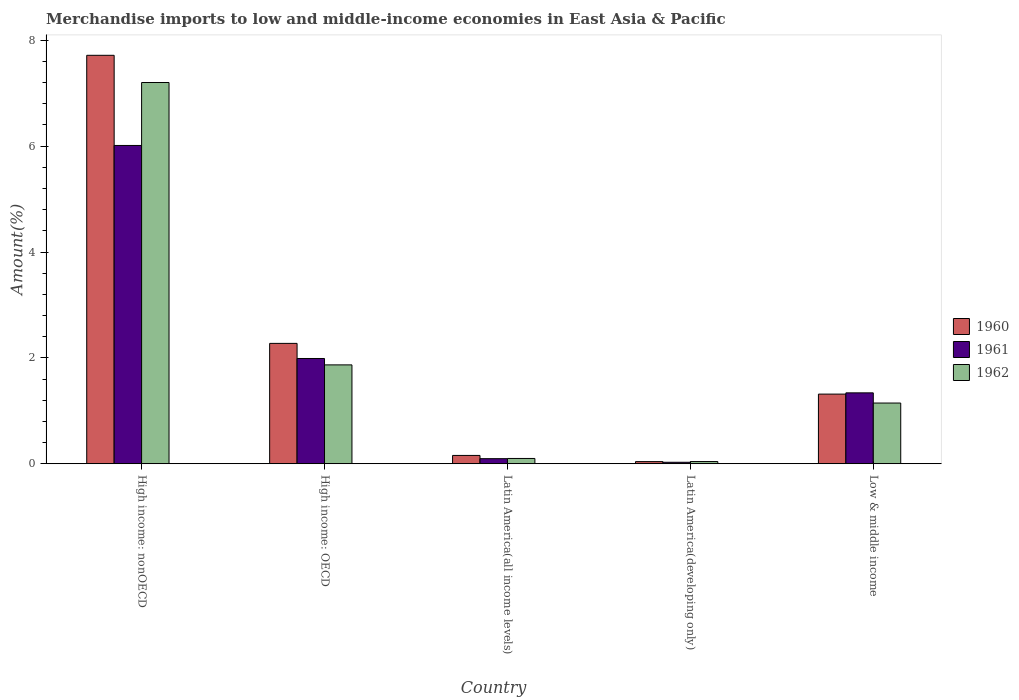How many different coloured bars are there?
Offer a terse response. 3. Are the number of bars per tick equal to the number of legend labels?
Provide a short and direct response. Yes. Are the number of bars on each tick of the X-axis equal?
Your answer should be very brief. Yes. In how many cases, is the number of bars for a given country not equal to the number of legend labels?
Give a very brief answer. 0. What is the percentage of amount earned from merchandise imports in 1962 in Latin America(all income levels)?
Provide a succinct answer. 0.1. Across all countries, what is the maximum percentage of amount earned from merchandise imports in 1961?
Ensure brevity in your answer.  6.01. Across all countries, what is the minimum percentage of amount earned from merchandise imports in 1961?
Your answer should be compact. 0.03. In which country was the percentage of amount earned from merchandise imports in 1961 maximum?
Give a very brief answer. High income: nonOECD. In which country was the percentage of amount earned from merchandise imports in 1960 minimum?
Offer a terse response. Latin America(developing only). What is the total percentage of amount earned from merchandise imports in 1961 in the graph?
Your answer should be compact. 9.46. What is the difference between the percentage of amount earned from merchandise imports in 1962 in Latin America(all income levels) and that in Low & middle income?
Make the answer very short. -1.05. What is the difference between the percentage of amount earned from merchandise imports in 1962 in Latin America(all income levels) and the percentage of amount earned from merchandise imports in 1960 in High income: OECD?
Your answer should be compact. -2.17. What is the average percentage of amount earned from merchandise imports in 1960 per country?
Provide a short and direct response. 2.3. What is the difference between the percentage of amount earned from merchandise imports of/in 1961 and percentage of amount earned from merchandise imports of/in 1962 in Low & middle income?
Provide a short and direct response. 0.19. In how many countries, is the percentage of amount earned from merchandise imports in 1961 greater than 2.4 %?
Make the answer very short. 1. What is the ratio of the percentage of amount earned from merchandise imports in 1961 in Latin America(all income levels) to that in Low & middle income?
Your response must be concise. 0.07. Is the difference between the percentage of amount earned from merchandise imports in 1961 in High income: OECD and Low & middle income greater than the difference between the percentage of amount earned from merchandise imports in 1962 in High income: OECD and Low & middle income?
Make the answer very short. No. What is the difference between the highest and the second highest percentage of amount earned from merchandise imports in 1962?
Offer a terse response. 0.72. What is the difference between the highest and the lowest percentage of amount earned from merchandise imports in 1961?
Your response must be concise. 5.99. Is the sum of the percentage of amount earned from merchandise imports in 1960 in High income: OECD and Latin America(all income levels) greater than the maximum percentage of amount earned from merchandise imports in 1962 across all countries?
Give a very brief answer. No. What does the 2nd bar from the left in High income: nonOECD represents?
Your answer should be compact. 1961. Is it the case that in every country, the sum of the percentage of amount earned from merchandise imports in 1962 and percentage of amount earned from merchandise imports in 1960 is greater than the percentage of amount earned from merchandise imports in 1961?
Ensure brevity in your answer.  Yes. Are all the bars in the graph horizontal?
Offer a very short reply. No. Are the values on the major ticks of Y-axis written in scientific E-notation?
Offer a terse response. No. Does the graph contain any zero values?
Give a very brief answer. No. What is the title of the graph?
Keep it short and to the point. Merchandise imports to low and middle-income economies in East Asia & Pacific. Does "1972" appear as one of the legend labels in the graph?
Provide a succinct answer. No. What is the label or title of the Y-axis?
Provide a short and direct response. Amount(%). What is the Amount(%) of 1960 in High income: nonOECD?
Offer a terse response. 7.72. What is the Amount(%) of 1961 in High income: nonOECD?
Provide a succinct answer. 6.01. What is the Amount(%) in 1962 in High income: nonOECD?
Keep it short and to the point. 7.2. What is the Amount(%) of 1960 in High income: OECD?
Offer a very short reply. 2.27. What is the Amount(%) of 1961 in High income: OECD?
Your answer should be very brief. 1.99. What is the Amount(%) of 1962 in High income: OECD?
Make the answer very short. 1.87. What is the Amount(%) of 1960 in Latin America(all income levels)?
Provide a succinct answer. 0.16. What is the Amount(%) of 1961 in Latin America(all income levels)?
Provide a short and direct response. 0.1. What is the Amount(%) of 1962 in Latin America(all income levels)?
Give a very brief answer. 0.1. What is the Amount(%) in 1960 in Latin America(developing only)?
Offer a very short reply. 0.04. What is the Amount(%) in 1961 in Latin America(developing only)?
Give a very brief answer. 0.03. What is the Amount(%) of 1962 in Latin America(developing only)?
Ensure brevity in your answer.  0.04. What is the Amount(%) of 1960 in Low & middle income?
Give a very brief answer. 1.32. What is the Amount(%) in 1961 in Low & middle income?
Your response must be concise. 1.34. What is the Amount(%) of 1962 in Low & middle income?
Your answer should be very brief. 1.15. Across all countries, what is the maximum Amount(%) in 1960?
Ensure brevity in your answer.  7.72. Across all countries, what is the maximum Amount(%) in 1961?
Keep it short and to the point. 6.01. Across all countries, what is the maximum Amount(%) of 1962?
Give a very brief answer. 7.2. Across all countries, what is the minimum Amount(%) in 1960?
Make the answer very short. 0.04. Across all countries, what is the minimum Amount(%) in 1961?
Ensure brevity in your answer.  0.03. Across all countries, what is the minimum Amount(%) in 1962?
Ensure brevity in your answer.  0.04. What is the total Amount(%) of 1960 in the graph?
Offer a very short reply. 11.5. What is the total Amount(%) of 1961 in the graph?
Offer a terse response. 9.46. What is the total Amount(%) in 1962 in the graph?
Your answer should be compact. 10.36. What is the difference between the Amount(%) of 1960 in High income: nonOECD and that in High income: OECD?
Your response must be concise. 5.44. What is the difference between the Amount(%) of 1961 in High income: nonOECD and that in High income: OECD?
Give a very brief answer. 4.02. What is the difference between the Amount(%) of 1962 in High income: nonOECD and that in High income: OECD?
Offer a terse response. 5.33. What is the difference between the Amount(%) in 1960 in High income: nonOECD and that in Latin America(all income levels)?
Keep it short and to the point. 7.56. What is the difference between the Amount(%) of 1961 in High income: nonOECD and that in Latin America(all income levels)?
Ensure brevity in your answer.  5.92. What is the difference between the Amount(%) of 1962 in High income: nonOECD and that in Latin America(all income levels)?
Offer a terse response. 7.1. What is the difference between the Amount(%) in 1960 in High income: nonOECD and that in Latin America(developing only)?
Make the answer very short. 7.68. What is the difference between the Amount(%) of 1961 in High income: nonOECD and that in Latin America(developing only)?
Keep it short and to the point. 5.99. What is the difference between the Amount(%) in 1962 in High income: nonOECD and that in Latin America(developing only)?
Offer a very short reply. 7.16. What is the difference between the Amount(%) of 1960 in High income: nonOECD and that in Low & middle income?
Make the answer very short. 6.4. What is the difference between the Amount(%) of 1961 in High income: nonOECD and that in Low & middle income?
Offer a terse response. 4.67. What is the difference between the Amount(%) in 1962 in High income: nonOECD and that in Low & middle income?
Offer a very short reply. 6.06. What is the difference between the Amount(%) of 1960 in High income: OECD and that in Latin America(all income levels)?
Make the answer very short. 2.12. What is the difference between the Amount(%) of 1961 in High income: OECD and that in Latin America(all income levels)?
Offer a very short reply. 1.89. What is the difference between the Amount(%) in 1962 in High income: OECD and that in Latin America(all income levels)?
Keep it short and to the point. 1.77. What is the difference between the Amount(%) in 1960 in High income: OECD and that in Latin America(developing only)?
Keep it short and to the point. 2.23. What is the difference between the Amount(%) of 1961 in High income: OECD and that in Latin America(developing only)?
Ensure brevity in your answer.  1.96. What is the difference between the Amount(%) in 1962 in High income: OECD and that in Latin America(developing only)?
Offer a terse response. 1.83. What is the difference between the Amount(%) of 1960 in High income: OECD and that in Low & middle income?
Keep it short and to the point. 0.96. What is the difference between the Amount(%) of 1961 in High income: OECD and that in Low & middle income?
Ensure brevity in your answer.  0.65. What is the difference between the Amount(%) in 1962 in High income: OECD and that in Low & middle income?
Provide a short and direct response. 0.72. What is the difference between the Amount(%) of 1960 in Latin America(all income levels) and that in Latin America(developing only)?
Give a very brief answer. 0.12. What is the difference between the Amount(%) of 1961 in Latin America(all income levels) and that in Latin America(developing only)?
Keep it short and to the point. 0.07. What is the difference between the Amount(%) of 1962 in Latin America(all income levels) and that in Latin America(developing only)?
Give a very brief answer. 0.06. What is the difference between the Amount(%) of 1960 in Latin America(all income levels) and that in Low & middle income?
Make the answer very short. -1.16. What is the difference between the Amount(%) in 1961 in Latin America(all income levels) and that in Low & middle income?
Make the answer very short. -1.24. What is the difference between the Amount(%) of 1962 in Latin America(all income levels) and that in Low & middle income?
Offer a terse response. -1.05. What is the difference between the Amount(%) of 1960 in Latin America(developing only) and that in Low & middle income?
Ensure brevity in your answer.  -1.28. What is the difference between the Amount(%) in 1961 in Latin America(developing only) and that in Low & middle income?
Provide a short and direct response. -1.31. What is the difference between the Amount(%) in 1962 in Latin America(developing only) and that in Low & middle income?
Provide a short and direct response. -1.11. What is the difference between the Amount(%) of 1960 in High income: nonOECD and the Amount(%) of 1961 in High income: OECD?
Your response must be concise. 5.73. What is the difference between the Amount(%) of 1960 in High income: nonOECD and the Amount(%) of 1962 in High income: OECD?
Offer a very short reply. 5.85. What is the difference between the Amount(%) in 1961 in High income: nonOECD and the Amount(%) in 1962 in High income: OECD?
Your response must be concise. 4.15. What is the difference between the Amount(%) of 1960 in High income: nonOECD and the Amount(%) of 1961 in Latin America(all income levels)?
Offer a terse response. 7.62. What is the difference between the Amount(%) of 1960 in High income: nonOECD and the Amount(%) of 1962 in Latin America(all income levels)?
Keep it short and to the point. 7.62. What is the difference between the Amount(%) of 1961 in High income: nonOECD and the Amount(%) of 1962 in Latin America(all income levels)?
Offer a terse response. 5.91. What is the difference between the Amount(%) in 1960 in High income: nonOECD and the Amount(%) in 1961 in Latin America(developing only)?
Your response must be concise. 7.69. What is the difference between the Amount(%) of 1960 in High income: nonOECD and the Amount(%) of 1962 in Latin America(developing only)?
Provide a succinct answer. 7.67. What is the difference between the Amount(%) of 1961 in High income: nonOECD and the Amount(%) of 1962 in Latin America(developing only)?
Offer a terse response. 5.97. What is the difference between the Amount(%) of 1960 in High income: nonOECD and the Amount(%) of 1961 in Low & middle income?
Give a very brief answer. 6.38. What is the difference between the Amount(%) of 1960 in High income: nonOECD and the Amount(%) of 1962 in Low & middle income?
Offer a very short reply. 6.57. What is the difference between the Amount(%) in 1961 in High income: nonOECD and the Amount(%) in 1962 in Low & middle income?
Make the answer very short. 4.87. What is the difference between the Amount(%) in 1960 in High income: OECD and the Amount(%) in 1961 in Latin America(all income levels)?
Your answer should be compact. 2.18. What is the difference between the Amount(%) in 1960 in High income: OECD and the Amount(%) in 1962 in Latin America(all income levels)?
Provide a succinct answer. 2.17. What is the difference between the Amount(%) of 1961 in High income: OECD and the Amount(%) of 1962 in Latin America(all income levels)?
Provide a succinct answer. 1.89. What is the difference between the Amount(%) in 1960 in High income: OECD and the Amount(%) in 1961 in Latin America(developing only)?
Make the answer very short. 2.25. What is the difference between the Amount(%) of 1960 in High income: OECD and the Amount(%) of 1962 in Latin America(developing only)?
Your response must be concise. 2.23. What is the difference between the Amount(%) in 1961 in High income: OECD and the Amount(%) in 1962 in Latin America(developing only)?
Your answer should be compact. 1.95. What is the difference between the Amount(%) of 1960 in High income: OECD and the Amount(%) of 1961 in Low & middle income?
Offer a very short reply. 0.93. What is the difference between the Amount(%) of 1960 in High income: OECD and the Amount(%) of 1962 in Low & middle income?
Provide a succinct answer. 1.13. What is the difference between the Amount(%) of 1961 in High income: OECD and the Amount(%) of 1962 in Low & middle income?
Your answer should be very brief. 0.84. What is the difference between the Amount(%) in 1960 in Latin America(all income levels) and the Amount(%) in 1961 in Latin America(developing only)?
Your response must be concise. 0.13. What is the difference between the Amount(%) in 1960 in Latin America(all income levels) and the Amount(%) in 1962 in Latin America(developing only)?
Your answer should be compact. 0.12. What is the difference between the Amount(%) of 1961 in Latin America(all income levels) and the Amount(%) of 1962 in Latin America(developing only)?
Offer a terse response. 0.05. What is the difference between the Amount(%) in 1960 in Latin America(all income levels) and the Amount(%) in 1961 in Low & middle income?
Your answer should be compact. -1.18. What is the difference between the Amount(%) in 1960 in Latin America(all income levels) and the Amount(%) in 1962 in Low & middle income?
Ensure brevity in your answer.  -0.99. What is the difference between the Amount(%) of 1961 in Latin America(all income levels) and the Amount(%) of 1962 in Low & middle income?
Your answer should be compact. -1.05. What is the difference between the Amount(%) in 1960 in Latin America(developing only) and the Amount(%) in 1961 in Low & middle income?
Provide a succinct answer. -1.3. What is the difference between the Amount(%) of 1960 in Latin America(developing only) and the Amount(%) of 1962 in Low & middle income?
Give a very brief answer. -1.11. What is the difference between the Amount(%) of 1961 in Latin America(developing only) and the Amount(%) of 1962 in Low & middle income?
Your answer should be compact. -1.12. What is the average Amount(%) in 1960 per country?
Provide a succinct answer. 2.3. What is the average Amount(%) in 1961 per country?
Offer a very short reply. 1.89. What is the average Amount(%) in 1962 per country?
Offer a terse response. 2.07. What is the difference between the Amount(%) in 1960 and Amount(%) in 1961 in High income: nonOECD?
Offer a terse response. 1.7. What is the difference between the Amount(%) in 1960 and Amount(%) in 1962 in High income: nonOECD?
Offer a terse response. 0.51. What is the difference between the Amount(%) in 1961 and Amount(%) in 1962 in High income: nonOECD?
Your answer should be compact. -1.19. What is the difference between the Amount(%) in 1960 and Amount(%) in 1961 in High income: OECD?
Ensure brevity in your answer.  0.29. What is the difference between the Amount(%) of 1960 and Amount(%) of 1962 in High income: OECD?
Make the answer very short. 0.41. What is the difference between the Amount(%) of 1961 and Amount(%) of 1962 in High income: OECD?
Provide a succinct answer. 0.12. What is the difference between the Amount(%) in 1960 and Amount(%) in 1961 in Latin America(all income levels)?
Provide a succinct answer. 0.06. What is the difference between the Amount(%) in 1960 and Amount(%) in 1962 in Latin America(all income levels)?
Keep it short and to the point. 0.06. What is the difference between the Amount(%) in 1961 and Amount(%) in 1962 in Latin America(all income levels)?
Your answer should be compact. -0. What is the difference between the Amount(%) in 1960 and Amount(%) in 1961 in Latin America(developing only)?
Your response must be concise. 0.01. What is the difference between the Amount(%) of 1960 and Amount(%) of 1962 in Latin America(developing only)?
Make the answer very short. -0. What is the difference between the Amount(%) of 1961 and Amount(%) of 1962 in Latin America(developing only)?
Your answer should be very brief. -0.01. What is the difference between the Amount(%) in 1960 and Amount(%) in 1961 in Low & middle income?
Offer a terse response. -0.02. What is the difference between the Amount(%) in 1960 and Amount(%) in 1962 in Low & middle income?
Make the answer very short. 0.17. What is the difference between the Amount(%) in 1961 and Amount(%) in 1962 in Low & middle income?
Provide a short and direct response. 0.19. What is the ratio of the Amount(%) in 1960 in High income: nonOECD to that in High income: OECD?
Provide a succinct answer. 3.39. What is the ratio of the Amount(%) of 1961 in High income: nonOECD to that in High income: OECD?
Your response must be concise. 3.02. What is the ratio of the Amount(%) of 1962 in High income: nonOECD to that in High income: OECD?
Provide a succinct answer. 3.86. What is the ratio of the Amount(%) of 1960 in High income: nonOECD to that in Latin America(all income levels)?
Ensure brevity in your answer.  49.18. What is the ratio of the Amount(%) of 1961 in High income: nonOECD to that in Latin America(all income levels)?
Keep it short and to the point. 62.77. What is the ratio of the Amount(%) in 1962 in High income: nonOECD to that in Latin America(all income levels)?
Provide a short and direct response. 72.3. What is the ratio of the Amount(%) in 1960 in High income: nonOECD to that in Latin America(developing only)?
Make the answer very short. 192.42. What is the ratio of the Amount(%) of 1961 in High income: nonOECD to that in Latin America(developing only)?
Keep it short and to the point. 216.41. What is the ratio of the Amount(%) in 1962 in High income: nonOECD to that in Latin America(developing only)?
Make the answer very short. 174.29. What is the ratio of the Amount(%) of 1960 in High income: nonOECD to that in Low & middle income?
Keep it short and to the point. 5.86. What is the ratio of the Amount(%) of 1961 in High income: nonOECD to that in Low & middle income?
Ensure brevity in your answer.  4.49. What is the ratio of the Amount(%) of 1962 in High income: nonOECD to that in Low & middle income?
Your response must be concise. 6.28. What is the ratio of the Amount(%) of 1960 in High income: OECD to that in Latin America(all income levels)?
Give a very brief answer. 14.49. What is the ratio of the Amount(%) of 1961 in High income: OECD to that in Latin America(all income levels)?
Keep it short and to the point. 20.76. What is the ratio of the Amount(%) in 1962 in High income: OECD to that in Latin America(all income levels)?
Provide a succinct answer. 18.75. What is the ratio of the Amount(%) of 1960 in High income: OECD to that in Latin America(developing only)?
Your answer should be compact. 56.7. What is the ratio of the Amount(%) in 1961 in High income: OECD to that in Latin America(developing only)?
Keep it short and to the point. 71.56. What is the ratio of the Amount(%) in 1962 in High income: OECD to that in Latin America(developing only)?
Ensure brevity in your answer.  45.19. What is the ratio of the Amount(%) in 1960 in High income: OECD to that in Low & middle income?
Your answer should be very brief. 1.73. What is the ratio of the Amount(%) in 1961 in High income: OECD to that in Low & middle income?
Offer a terse response. 1.48. What is the ratio of the Amount(%) of 1962 in High income: OECD to that in Low & middle income?
Offer a terse response. 1.63. What is the ratio of the Amount(%) of 1960 in Latin America(all income levels) to that in Latin America(developing only)?
Offer a terse response. 3.91. What is the ratio of the Amount(%) of 1961 in Latin America(all income levels) to that in Latin America(developing only)?
Your answer should be very brief. 3.45. What is the ratio of the Amount(%) in 1962 in Latin America(all income levels) to that in Latin America(developing only)?
Keep it short and to the point. 2.41. What is the ratio of the Amount(%) in 1960 in Latin America(all income levels) to that in Low & middle income?
Offer a very short reply. 0.12. What is the ratio of the Amount(%) of 1961 in Latin America(all income levels) to that in Low & middle income?
Provide a succinct answer. 0.07. What is the ratio of the Amount(%) in 1962 in Latin America(all income levels) to that in Low & middle income?
Provide a short and direct response. 0.09. What is the ratio of the Amount(%) of 1960 in Latin America(developing only) to that in Low & middle income?
Offer a terse response. 0.03. What is the ratio of the Amount(%) in 1961 in Latin America(developing only) to that in Low & middle income?
Your response must be concise. 0.02. What is the ratio of the Amount(%) of 1962 in Latin America(developing only) to that in Low & middle income?
Keep it short and to the point. 0.04. What is the difference between the highest and the second highest Amount(%) in 1960?
Ensure brevity in your answer.  5.44. What is the difference between the highest and the second highest Amount(%) of 1961?
Make the answer very short. 4.02. What is the difference between the highest and the second highest Amount(%) in 1962?
Offer a very short reply. 5.33. What is the difference between the highest and the lowest Amount(%) of 1960?
Offer a terse response. 7.68. What is the difference between the highest and the lowest Amount(%) in 1961?
Ensure brevity in your answer.  5.99. What is the difference between the highest and the lowest Amount(%) of 1962?
Provide a short and direct response. 7.16. 